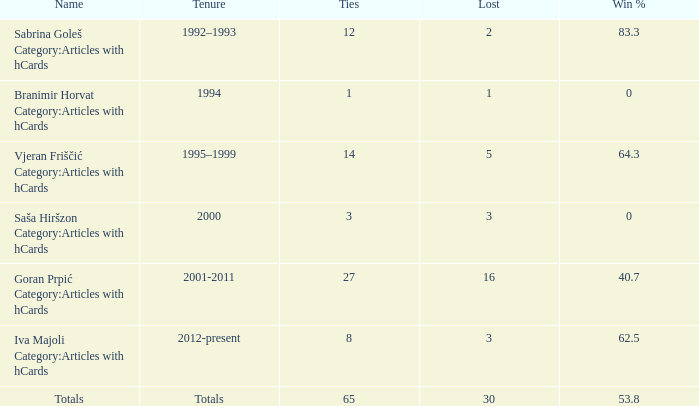Could you parse the entire table as a dict? {'header': ['Name', 'Tenure', 'Ties', 'Lost', 'Win %'], 'rows': [['Sabrina Goleš Category:Articles with hCards', '1992–1993', '12', '2', '83.3'], ['Branimir Horvat Category:Articles with hCards', '1994', '1', '1', '0'], ['Vjeran Friščić Category:Articles with hCards', '1995–1999', '14', '5', '64.3'], ['Saša Hiršzon Category:Articles with hCards', '2000', '3', '3', '0'], ['Goran Prpić Category:Articles with hCards', '2001-2011', '27', '16', '40.7'], ['Iva Majoli Category:Articles with hCards', '2012-present', '8', '3', '62.5'], ['Totals', 'Totals', '65', '30', '53.8']]} What is the total count of ties for win percentage greater than 0 and duration of 2001-2011 with losses exceeding 16? 0.0. 